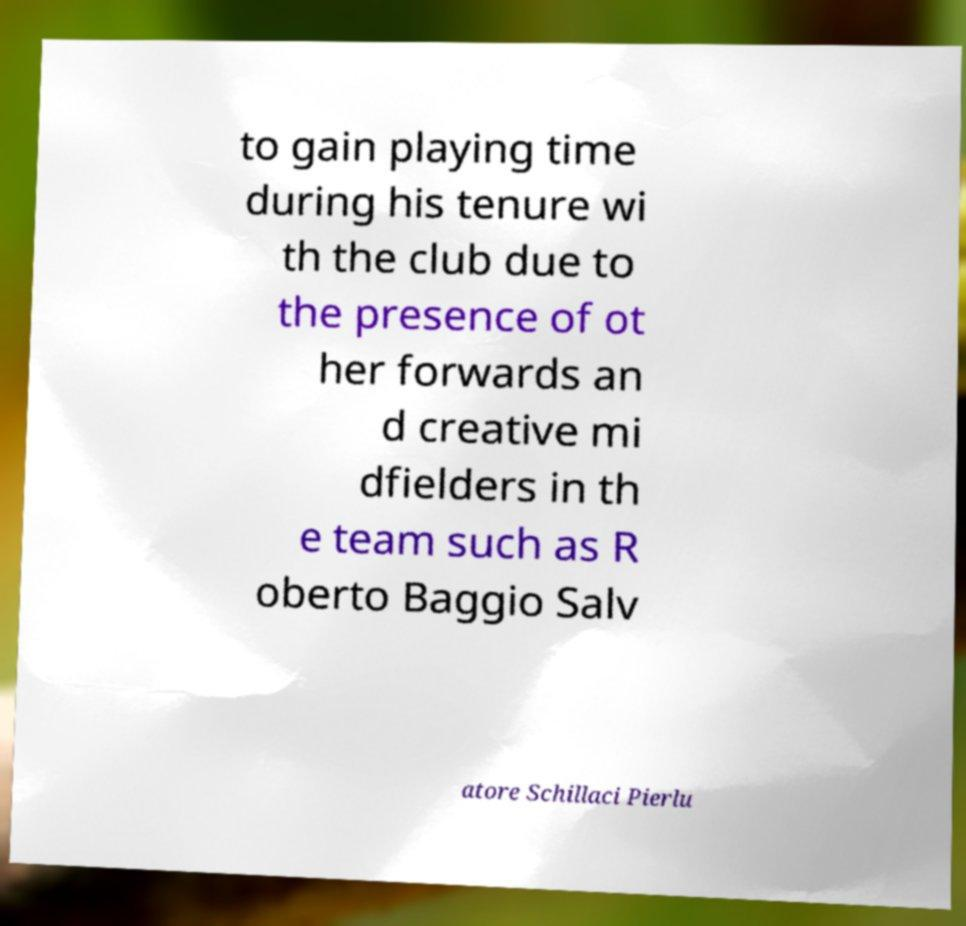What messages or text are displayed in this image? I need them in a readable, typed format. to gain playing time during his tenure wi th the club due to the presence of ot her forwards an d creative mi dfielders in th e team such as R oberto Baggio Salv atore Schillaci Pierlu 